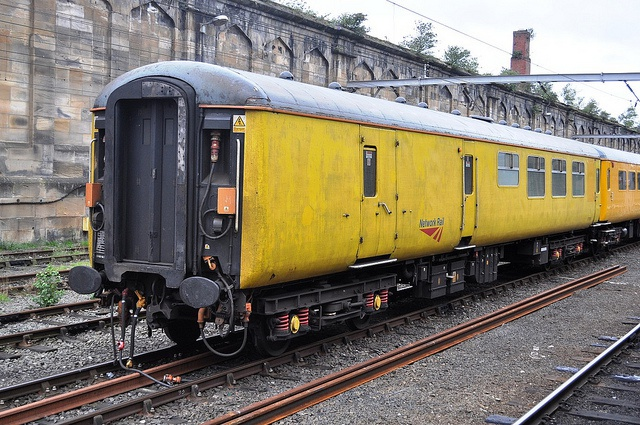Describe the objects in this image and their specific colors. I can see a train in gray, black, gold, and tan tones in this image. 